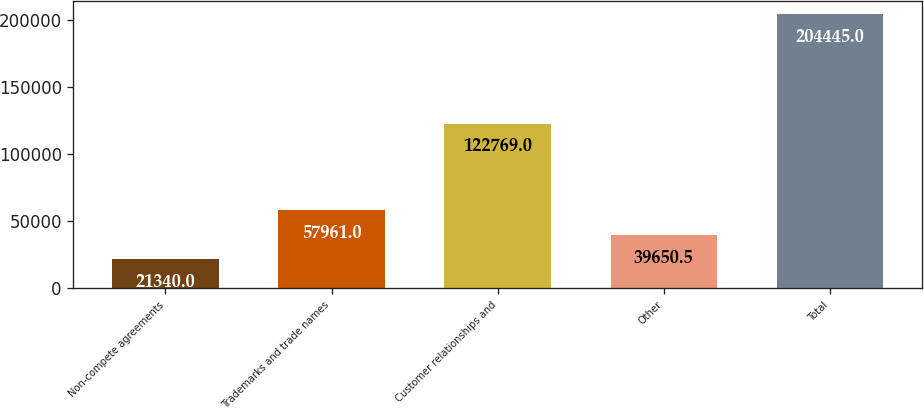Convert chart to OTSL. <chart><loc_0><loc_0><loc_500><loc_500><bar_chart><fcel>Non-compete agreements<fcel>Trademarks and trade names<fcel>Customer relationships and<fcel>Other<fcel>Total<nl><fcel>21340<fcel>57961<fcel>122769<fcel>39650.5<fcel>204445<nl></chart> 